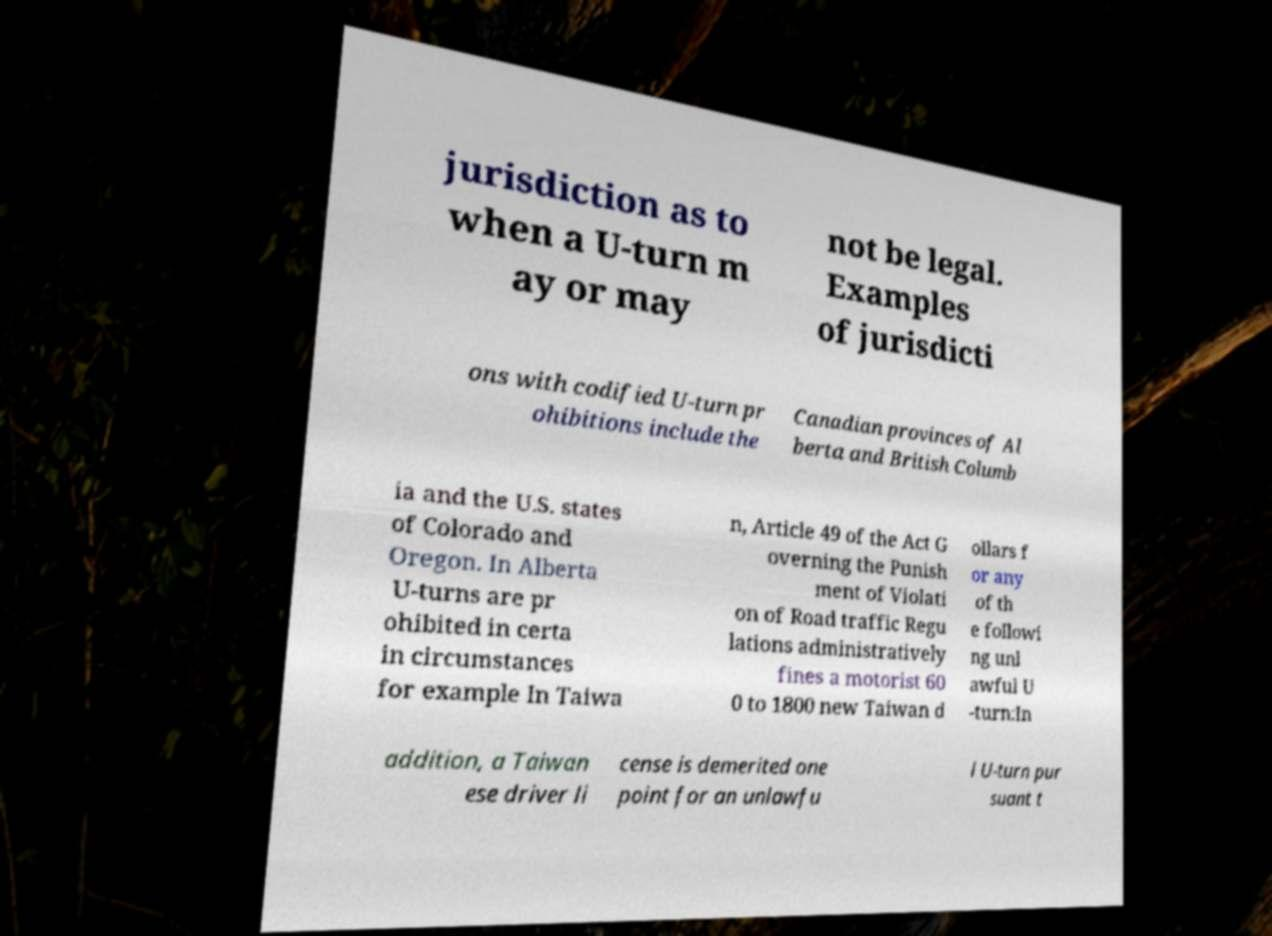Could you extract and type out the text from this image? jurisdiction as to when a U-turn m ay or may not be legal. Examples of jurisdicti ons with codified U-turn pr ohibitions include the Canadian provinces of Al berta and British Columb ia and the U.S. states of Colorado and Oregon. In Alberta U-turns are pr ohibited in certa in circumstances for example In Taiwa n, Article 49 of the Act G overning the Punish ment of Violati on of Road traffic Regu lations administratively fines a motorist 60 0 to 1800 new Taiwan d ollars f or any of th e followi ng unl awful U -turn:In addition, a Taiwan ese driver li cense is demerited one point for an unlawfu l U-turn pur suant t 